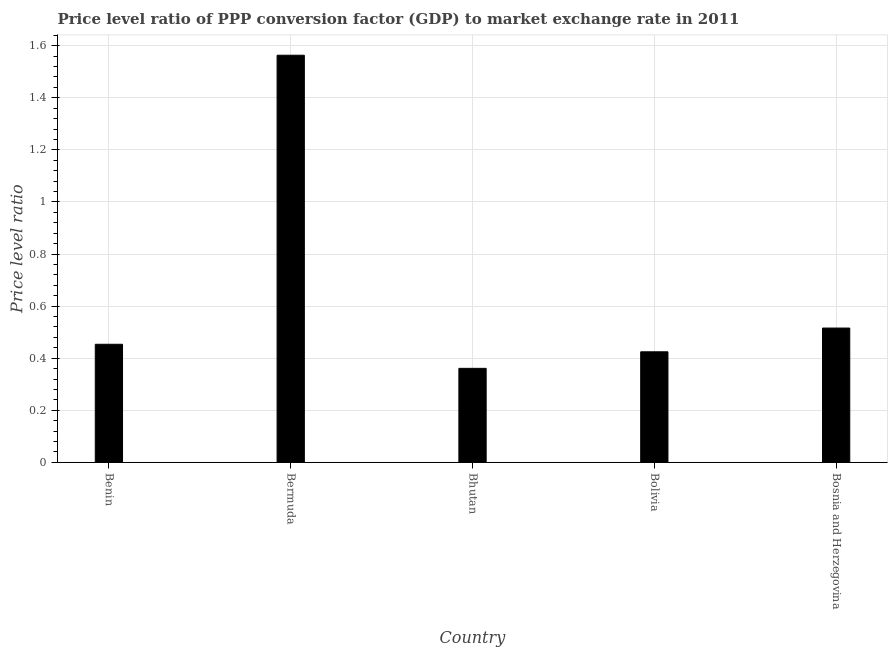Does the graph contain grids?
Make the answer very short. Yes. What is the title of the graph?
Your answer should be compact. Price level ratio of PPP conversion factor (GDP) to market exchange rate in 2011. What is the label or title of the Y-axis?
Your response must be concise. Price level ratio. What is the price level ratio in Bermuda?
Your response must be concise. 1.56. Across all countries, what is the maximum price level ratio?
Give a very brief answer. 1.56. Across all countries, what is the minimum price level ratio?
Offer a terse response. 0.36. In which country was the price level ratio maximum?
Provide a short and direct response. Bermuda. In which country was the price level ratio minimum?
Offer a very short reply. Bhutan. What is the sum of the price level ratio?
Your response must be concise. 3.32. What is the difference between the price level ratio in Bermuda and Bhutan?
Offer a very short reply. 1.2. What is the average price level ratio per country?
Keep it short and to the point. 0.66. What is the median price level ratio?
Make the answer very short. 0.45. In how many countries, is the price level ratio greater than 0.16 ?
Offer a very short reply. 5. What is the ratio of the price level ratio in Bhutan to that in Bolivia?
Your response must be concise. 0.85. Is the difference between the price level ratio in Bermuda and Bosnia and Herzegovina greater than the difference between any two countries?
Provide a short and direct response. No. What is the difference between the highest and the second highest price level ratio?
Provide a short and direct response. 1.05. In how many countries, is the price level ratio greater than the average price level ratio taken over all countries?
Make the answer very short. 1. Are all the bars in the graph horizontal?
Provide a succinct answer. No. How many countries are there in the graph?
Provide a succinct answer. 5. What is the difference between two consecutive major ticks on the Y-axis?
Your answer should be very brief. 0.2. Are the values on the major ticks of Y-axis written in scientific E-notation?
Your answer should be compact. No. What is the Price level ratio of Benin?
Provide a succinct answer. 0.45. What is the Price level ratio in Bermuda?
Offer a very short reply. 1.56. What is the Price level ratio in Bhutan?
Offer a very short reply. 0.36. What is the Price level ratio of Bolivia?
Your response must be concise. 0.42. What is the Price level ratio in Bosnia and Herzegovina?
Your answer should be very brief. 0.52. What is the difference between the Price level ratio in Benin and Bermuda?
Keep it short and to the point. -1.11. What is the difference between the Price level ratio in Benin and Bhutan?
Provide a short and direct response. 0.09. What is the difference between the Price level ratio in Benin and Bolivia?
Make the answer very short. 0.03. What is the difference between the Price level ratio in Benin and Bosnia and Herzegovina?
Provide a short and direct response. -0.06. What is the difference between the Price level ratio in Bermuda and Bhutan?
Your answer should be very brief. 1.2. What is the difference between the Price level ratio in Bermuda and Bolivia?
Offer a very short reply. 1.14. What is the difference between the Price level ratio in Bermuda and Bosnia and Herzegovina?
Your answer should be very brief. 1.05. What is the difference between the Price level ratio in Bhutan and Bolivia?
Provide a succinct answer. -0.06. What is the difference between the Price level ratio in Bhutan and Bosnia and Herzegovina?
Provide a short and direct response. -0.15. What is the difference between the Price level ratio in Bolivia and Bosnia and Herzegovina?
Keep it short and to the point. -0.09. What is the ratio of the Price level ratio in Benin to that in Bermuda?
Offer a very short reply. 0.29. What is the ratio of the Price level ratio in Benin to that in Bhutan?
Your answer should be compact. 1.26. What is the ratio of the Price level ratio in Benin to that in Bolivia?
Your response must be concise. 1.07. What is the ratio of the Price level ratio in Benin to that in Bosnia and Herzegovina?
Give a very brief answer. 0.88. What is the ratio of the Price level ratio in Bermuda to that in Bhutan?
Your answer should be very brief. 4.33. What is the ratio of the Price level ratio in Bermuda to that in Bolivia?
Keep it short and to the point. 3.68. What is the ratio of the Price level ratio in Bermuda to that in Bosnia and Herzegovina?
Your response must be concise. 3.03. What is the ratio of the Price level ratio in Bhutan to that in Bolivia?
Provide a short and direct response. 0.85. What is the ratio of the Price level ratio in Bhutan to that in Bosnia and Herzegovina?
Provide a short and direct response. 0.7. What is the ratio of the Price level ratio in Bolivia to that in Bosnia and Herzegovina?
Your response must be concise. 0.82. 